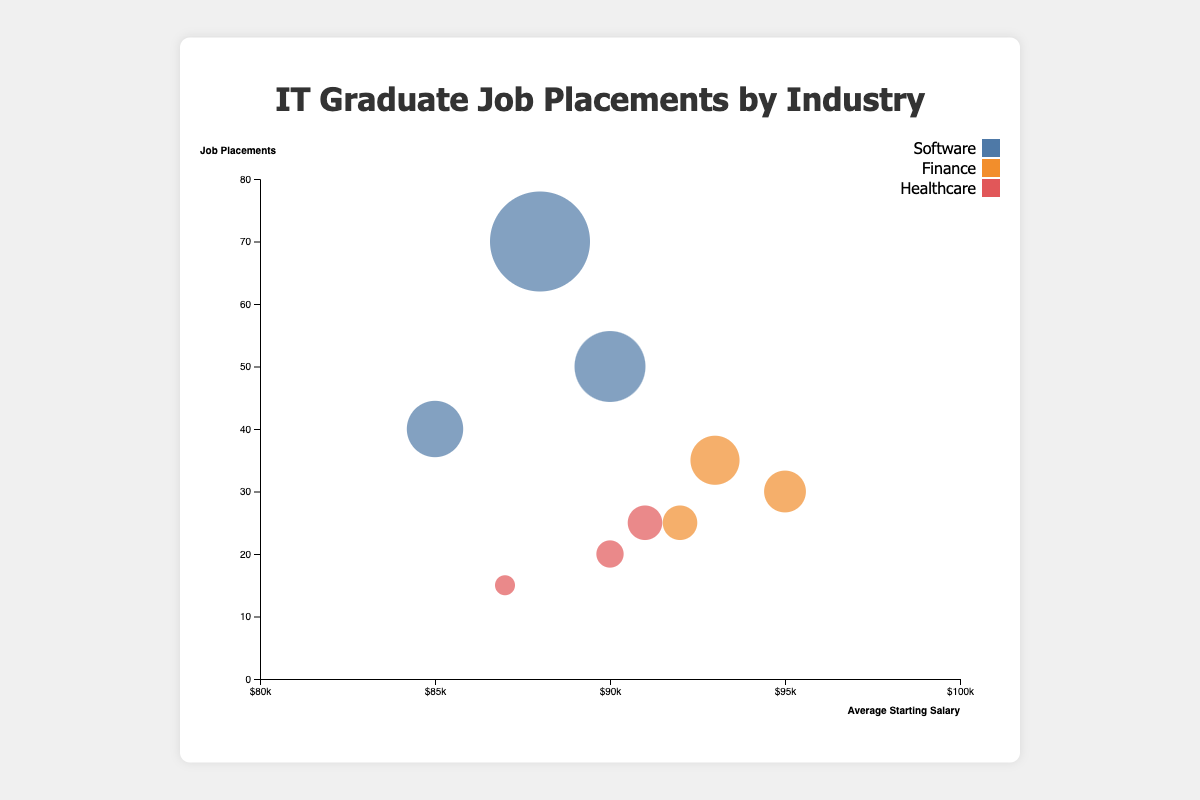What is the average starting salary in the healthcare industry? The average starting salaries for Pfizer, Johnson & Johnson, and UnitedHealth Group are $90,000, $91,000, and $87,000 respectively. Adding these gives $90,000 + $91,000 + $87,000 = $268,000, and dividing by the number of companies (3) results in $268,000 / 3.
Answer: $89,333 Which company in the finance industry has the highest job placements? In the finance industry, we look at the data points for Goldman Sachs, JPMorgan Chase, and Morgan Stanley. Goldman Sachs has 30 job placements, JPMorgan Chase has 35, and Morgan Stanley has 25. The highest number is 35, which corresponds to JPMorgan Chase.
Answer: JPMorgan Chase What is the relationship between average starting salary and job placements for software companies? For software companies, Google has 50 job placements with a $90,000 salary, Microsoft has 40 job placements with $85,000, and Amazon has 70 job placements with $88,000. As the job placements increase from Microsoft (40) to Amazon (70), the salary shows a mildly fluctuating but close range from $85,000 to $88,000 to $90,000.
Answer: Slight fluctuation, generally high Which industry has the company with the highest average starting salary? We need to look at the highest average starting salary in each industry. In Software, it is Google with $90,000. In Finance, Goldman Sachs has $95,000, which is the highest among all companies listed. In Healthcare, the highest is Johnson & Johnson with $91,000. Hence, the company with the highest average starting salary is in the Finance industry.
Answer: Finance How many companies have job placements greater than 50? From the data points, only Amazon (70) and Google (50) have job placements of 50 or more.
Answer: 2 Which companies have the same average starting salary and what is it? Google in Software ($90,000) and Pfizer in Healthcare ($90,000) have the same average starting salary.
Answer: Google, Pfizer; $90,000 Compare the job placements between the highest and lowest in the software industry. In the software industry, Amazon has the highest with 70 job placements and Microsoft has the lowest with 40 job placements. The difference is 70 - 40.
Answer: 30 Identify the industry with the most variation in average starting salary. For Software, the range is $90,000 - $85,000 = $5,000. For Finance, the range is $95,000 - $92,000 = $3,000. For Healthcare, the range is $91,000 - $87,000 = $4,000. The software industry has the highest variation.
Answer: Software, $5,000 Which industry overall has the highest average starting salary when considering the industry averages and how is this calculated? Calculate the average for each industry: For Software: ($90,000 + $85,000 + $88,000) / 3 = $87,667. For Finance: ($95,000 + $93,000 + $92,000) / 3 = $93,333. For Healthcare: ($90,000 + $91,000 + $87,000) / 3 = $89,333. Finance has the highest average.
Answer: Finance, $93,333 